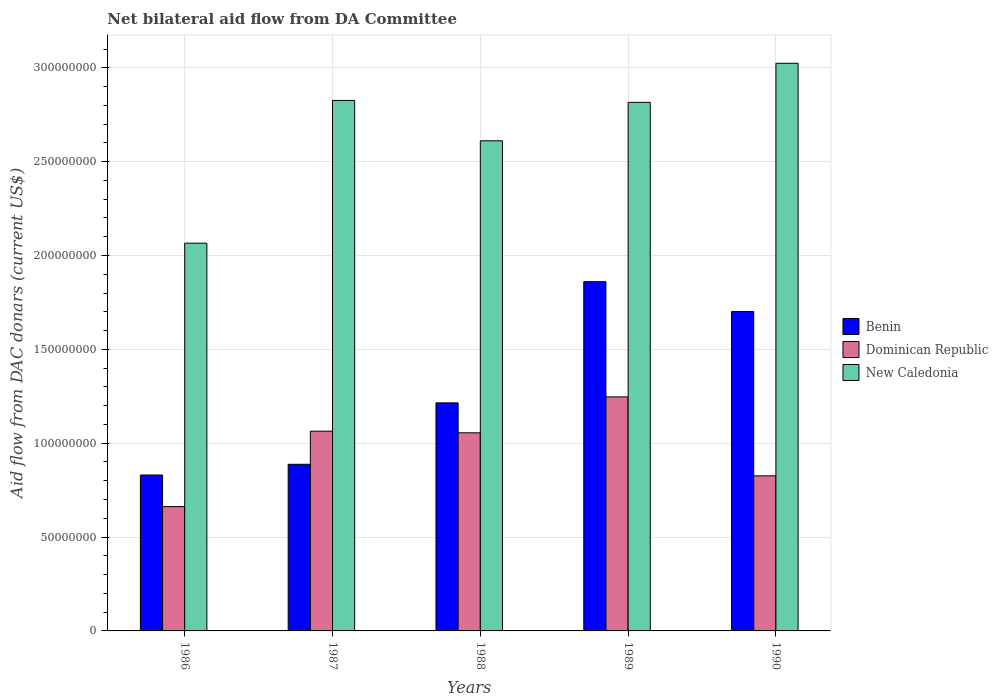How many groups of bars are there?
Provide a short and direct response. 5. Are the number of bars per tick equal to the number of legend labels?
Make the answer very short. Yes. Are the number of bars on each tick of the X-axis equal?
Provide a short and direct response. Yes. How many bars are there on the 3rd tick from the left?
Give a very brief answer. 3. In how many cases, is the number of bars for a given year not equal to the number of legend labels?
Ensure brevity in your answer.  0. What is the aid flow in in Dominican Republic in 1988?
Provide a short and direct response. 1.06e+08. Across all years, what is the maximum aid flow in in Benin?
Offer a very short reply. 1.86e+08. Across all years, what is the minimum aid flow in in Dominican Republic?
Provide a short and direct response. 6.62e+07. In which year was the aid flow in in Dominican Republic maximum?
Make the answer very short. 1989. In which year was the aid flow in in New Caledonia minimum?
Your answer should be very brief. 1986. What is the total aid flow in in Benin in the graph?
Give a very brief answer. 6.50e+08. What is the difference between the aid flow in in Dominican Republic in 1987 and that in 1989?
Make the answer very short. -1.83e+07. What is the average aid flow in in New Caledonia per year?
Ensure brevity in your answer.  2.67e+08. In the year 1986, what is the difference between the aid flow in in New Caledonia and aid flow in in Dominican Republic?
Make the answer very short. 1.40e+08. In how many years, is the aid flow in in Dominican Republic greater than 150000000 US$?
Give a very brief answer. 0. What is the ratio of the aid flow in in New Caledonia in 1987 to that in 1990?
Make the answer very short. 0.93. Is the aid flow in in Dominican Republic in 1988 less than that in 1990?
Your response must be concise. No. Is the difference between the aid flow in in New Caledonia in 1988 and 1990 greater than the difference between the aid flow in in Dominican Republic in 1988 and 1990?
Offer a terse response. No. What is the difference between the highest and the second highest aid flow in in Dominican Republic?
Your response must be concise. 1.83e+07. What is the difference between the highest and the lowest aid flow in in Dominican Republic?
Offer a very short reply. 5.84e+07. Is the sum of the aid flow in in Dominican Republic in 1987 and 1990 greater than the maximum aid flow in in New Caledonia across all years?
Offer a very short reply. No. What does the 3rd bar from the left in 1987 represents?
Offer a very short reply. New Caledonia. What does the 2nd bar from the right in 1990 represents?
Your response must be concise. Dominican Republic. Is it the case that in every year, the sum of the aid flow in in Dominican Republic and aid flow in in New Caledonia is greater than the aid flow in in Benin?
Provide a short and direct response. Yes. How many years are there in the graph?
Provide a short and direct response. 5. What is the difference between two consecutive major ticks on the Y-axis?
Offer a very short reply. 5.00e+07. Are the values on the major ticks of Y-axis written in scientific E-notation?
Your answer should be very brief. No. Does the graph contain any zero values?
Make the answer very short. No. What is the title of the graph?
Your answer should be very brief. Net bilateral aid flow from DA Committee. What is the label or title of the Y-axis?
Ensure brevity in your answer.  Aid flow from DAC donars (current US$). What is the Aid flow from DAC donars (current US$) in Benin in 1986?
Offer a terse response. 8.31e+07. What is the Aid flow from DAC donars (current US$) of Dominican Republic in 1986?
Your answer should be very brief. 6.62e+07. What is the Aid flow from DAC donars (current US$) of New Caledonia in 1986?
Your answer should be compact. 2.07e+08. What is the Aid flow from DAC donars (current US$) in Benin in 1987?
Provide a succinct answer. 8.88e+07. What is the Aid flow from DAC donars (current US$) of Dominican Republic in 1987?
Provide a succinct answer. 1.06e+08. What is the Aid flow from DAC donars (current US$) of New Caledonia in 1987?
Provide a short and direct response. 2.83e+08. What is the Aid flow from DAC donars (current US$) of Benin in 1988?
Provide a short and direct response. 1.21e+08. What is the Aid flow from DAC donars (current US$) of Dominican Republic in 1988?
Offer a terse response. 1.06e+08. What is the Aid flow from DAC donars (current US$) in New Caledonia in 1988?
Your answer should be compact. 2.61e+08. What is the Aid flow from DAC donars (current US$) in Benin in 1989?
Make the answer very short. 1.86e+08. What is the Aid flow from DAC donars (current US$) of Dominican Republic in 1989?
Keep it short and to the point. 1.25e+08. What is the Aid flow from DAC donars (current US$) of New Caledonia in 1989?
Your answer should be compact. 2.82e+08. What is the Aid flow from DAC donars (current US$) of Benin in 1990?
Keep it short and to the point. 1.70e+08. What is the Aid flow from DAC donars (current US$) of Dominican Republic in 1990?
Your response must be concise. 8.26e+07. What is the Aid flow from DAC donars (current US$) in New Caledonia in 1990?
Ensure brevity in your answer.  3.02e+08. Across all years, what is the maximum Aid flow from DAC donars (current US$) of Benin?
Provide a succinct answer. 1.86e+08. Across all years, what is the maximum Aid flow from DAC donars (current US$) of Dominican Republic?
Provide a succinct answer. 1.25e+08. Across all years, what is the maximum Aid flow from DAC donars (current US$) of New Caledonia?
Ensure brevity in your answer.  3.02e+08. Across all years, what is the minimum Aid flow from DAC donars (current US$) in Benin?
Offer a terse response. 8.31e+07. Across all years, what is the minimum Aid flow from DAC donars (current US$) of Dominican Republic?
Your response must be concise. 6.62e+07. Across all years, what is the minimum Aid flow from DAC donars (current US$) in New Caledonia?
Your answer should be very brief. 2.07e+08. What is the total Aid flow from DAC donars (current US$) of Benin in the graph?
Ensure brevity in your answer.  6.50e+08. What is the total Aid flow from DAC donars (current US$) in Dominican Republic in the graph?
Ensure brevity in your answer.  4.85e+08. What is the total Aid flow from DAC donars (current US$) in New Caledonia in the graph?
Your response must be concise. 1.33e+09. What is the difference between the Aid flow from DAC donars (current US$) of Benin in 1986 and that in 1987?
Your answer should be very brief. -5.71e+06. What is the difference between the Aid flow from DAC donars (current US$) in Dominican Republic in 1986 and that in 1987?
Provide a succinct answer. -4.02e+07. What is the difference between the Aid flow from DAC donars (current US$) of New Caledonia in 1986 and that in 1987?
Make the answer very short. -7.60e+07. What is the difference between the Aid flow from DAC donars (current US$) in Benin in 1986 and that in 1988?
Your answer should be compact. -3.84e+07. What is the difference between the Aid flow from DAC donars (current US$) of Dominican Republic in 1986 and that in 1988?
Your answer should be very brief. -3.93e+07. What is the difference between the Aid flow from DAC donars (current US$) of New Caledonia in 1986 and that in 1988?
Your response must be concise. -5.45e+07. What is the difference between the Aid flow from DAC donars (current US$) of Benin in 1986 and that in 1989?
Offer a terse response. -1.03e+08. What is the difference between the Aid flow from DAC donars (current US$) of Dominican Republic in 1986 and that in 1989?
Your response must be concise. -5.84e+07. What is the difference between the Aid flow from DAC donars (current US$) in New Caledonia in 1986 and that in 1989?
Provide a short and direct response. -7.50e+07. What is the difference between the Aid flow from DAC donars (current US$) in Benin in 1986 and that in 1990?
Make the answer very short. -8.71e+07. What is the difference between the Aid flow from DAC donars (current US$) in Dominican Republic in 1986 and that in 1990?
Your answer should be compact. -1.64e+07. What is the difference between the Aid flow from DAC donars (current US$) in New Caledonia in 1986 and that in 1990?
Provide a short and direct response. -9.58e+07. What is the difference between the Aid flow from DAC donars (current US$) of Benin in 1987 and that in 1988?
Keep it short and to the point. -3.27e+07. What is the difference between the Aid flow from DAC donars (current US$) of Dominican Republic in 1987 and that in 1988?
Give a very brief answer. 8.70e+05. What is the difference between the Aid flow from DAC donars (current US$) of New Caledonia in 1987 and that in 1988?
Keep it short and to the point. 2.15e+07. What is the difference between the Aid flow from DAC donars (current US$) in Benin in 1987 and that in 1989?
Give a very brief answer. -9.73e+07. What is the difference between the Aid flow from DAC donars (current US$) of Dominican Republic in 1987 and that in 1989?
Give a very brief answer. -1.83e+07. What is the difference between the Aid flow from DAC donars (current US$) of New Caledonia in 1987 and that in 1989?
Provide a short and direct response. 1.03e+06. What is the difference between the Aid flow from DAC donars (current US$) of Benin in 1987 and that in 1990?
Offer a very short reply. -8.14e+07. What is the difference between the Aid flow from DAC donars (current US$) in Dominican Republic in 1987 and that in 1990?
Offer a terse response. 2.38e+07. What is the difference between the Aid flow from DAC donars (current US$) of New Caledonia in 1987 and that in 1990?
Provide a short and direct response. -1.98e+07. What is the difference between the Aid flow from DAC donars (current US$) in Benin in 1988 and that in 1989?
Your answer should be compact. -6.46e+07. What is the difference between the Aid flow from DAC donars (current US$) of Dominican Republic in 1988 and that in 1989?
Your response must be concise. -1.91e+07. What is the difference between the Aid flow from DAC donars (current US$) of New Caledonia in 1988 and that in 1989?
Make the answer very short. -2.05e+07. What is the difference between the Aid flow from DAC donars (current US$) of Benin in 1988 and that in 1990?
Provide a short and direct response. -4.87e+07. What is the difference between the Aid flow from DAC donars (current US$) in Dominican Republic in 1988 and that in 1990?
Ensure brevity in your answer.  2.29e+07. What is the difference between the Aid flow from DAC donars (current US$) of New Caledonia in 1988 and that in 1990?
Your answer should be compact. -4.13e+07. What is the difference between the Aid flow from DAC donars (current US$) of Benin in 1989 and that in 1990?
Offer a very short reply. 1.59e+07. What is the difference between the Aid flow from DAC donars (current US$) of Dominican Republic in 1989 and that in 1990?
Make the answer very short. 4.20e+07. What is the difference between the Aid flow from DAC donars (current US$) in New Caledonia in 1989 and that in 1990?
Make the answer very short. -2.08e+07. What is the difference between the Aid flow from DAC donars (current US$) of Benin in 1986 and the Aid flow from DAC donars (current US$) of Dominican Republic in 1987?
Offer a very short reply. -2.34e+07. What is the difference between the Aid flow from DAC donars (current US$) of Benin in 1986 and the Aid flow from DAC donars (current US$) of New Caledonia in 1987?
Make the answer very short. -2.00e+08. What is the difference between the Aid flow from DAC donars (current US$) in Dominican Republic in 1986 and the Aid flow from DAC donars (current US$) in New Caledonia in 1987?
Offer a very short reply. -2.16e+08. What is the difference between the Aid flow from DAC donars (current US$) in Benin in 1986 and the Aid flow from DAC donars (current US$) in Dominican Republic in 1988?
Give a very brief answer. -2.25e+07. What is the difference between the Aid flow from DAC donars (current US$) of Benin in 1986 and the Aid flow from DAC donars (current US$) of New Caledonia in 1988?
Ensure brevity in your answer.  -1.78e+08. What is the difference between the Aid flow from DAC donars (current US$) in Dominican Republic in 1986 and the Aid flow from DAC donars (current US$) in New Caledonia in 1988?
Your answer should be compact. -1.95e+08. What is the difference between the Aid flow from DAC donars (current US$) of Benin in 1986 and the Aid flow from DAC donars (current US$) of Dominican Republic in 1989?
Provide a succinct answer. -4.16e+07. What is the difference between the Aid flow from DAC donars (current US$) in Benin in 1986 and the Aid flow from DAC donars (current US$) in New Caledonia in 1989?
Provide a succinct answer. -1.99e+08. What is the difference between the Aid flow from DAC donars (current US$) of Dominican Republic in 1986 and the Aid flow from DAC donars (current US$) of New Caledonia in 1989?
Keep it short and to the point. -2.15e+08. What is the difference between the Aid flow from DAC donars (current US$) in Benin in 1986 and the Aid flow from DAC donars (current US$) in Dominican Republic in 1990?
Keep it short and to the point. 4.40e+05. What is the difference between the Aid flow from DAC donars (current US$) of Benin in 1986 and the Aid flow from DAC donars (current US$) of New Caledonia in 1990?
Offer a very short reply. -2.19e+08. What is the difference between the Aid flow from DAC donars (current US$) of Dominican Republic in 1986 and the Aid flow from DAC donars (current US$) of New Caledonia in 1990?
Offer a terse response. -2.36e+08. What is the difference between the Aid flow from DAC donars (current US$) of Benin in 1987 and the Aid flow from DAC donars (current US$) of Dominican Republic in 1988?
Offer a terse response. -1.68e+07. What is the difference between the Aid flow from DAC donars (current US$) of Benin in 1987 and the Aid flow from DAC donars (current US$) of New Caledonia in 1988?
Offer a very short reply. -1.72e+08. What is the difference between the Aid flow from DAC donars (current US$) of Dominican Republic in 1987 and the Aid flow from DAC donars (current US$) of New Caledonia in 1988?
Ensure brevity in your answer.  -1.55e+08. What is the difference between the Aid flow from DAC donars (current US$) in Benin in 1987 and the Aid flow from DAC donars (current US$) in Dominican Republic in 1989?
Give a very brief answer. -3.59e+07. What is the difference between the Aid flow from DAC donars (current US$) in Benin in 1987 and the Aid flow from DAC donars (current US$) in New Caledonia in 1989?
Give a very brief answer. -1.93e+08. What is the difference between the Aid flow from DAC donars (current US$) of Dominican Republic in 1987 and the Aid flow from DAC donars (current US$) of New Caledonia in 1989?
Provide a short and direct response. -1.75e+08. What is the difference between the Aid flow from DAC donars (current US$) of Benin in 1987 and the Aid flow from DAC donars (current US$) of Dominican Republic in 1990?
Your response must be concise. 6.15e+06. What is the difference between the Aid flow from DAC donars (current US$) in Benin in 1987 and the Aid flow from DAC donars (current US$) in New Caledonia in 1990?
Provide a succinct answer. -2.14e+08. What is the difference between the Aid flow from DAC donars (current US$) in Dominican Republic in 1987 and the Aid flow from DAC donars (current US$) in New Caledonia in 1990?
Offer a terse response. -1.96e+08. What is the difference between the Aid flow from DAC donars (current US$) in Benin in 1988 and the Aid flow from DAC donars (current US$) in Dominican Republic in 1989?
Your answer should be compact. -3.19e+06. What is the difference between the Aid flow from DAC donars (current US$) in Benin in 1988 and the Aid flow from DAC donars (current US$) in New Caledonia in 1989?
Provide a short and direct response. -1.60e+08. What is the difference between the Aid flow from DAC donars (current US$) in Dominican Republic in 1988 and the Aid flow from DAC donars (current US$) in New Caledonia in 1989?
Provide a succinct answer. -1.76e+08. What is the difference between the Aid flow from DAC donars (current US$) of Benin in 1988 and the Aid flow from DAC donars (current US$) of Dominican Republic in 1990?
Your answer should be very brief. 3.89e+07. What is the difference between the Aid flow from DAC donars (current US$) in Benin in 1988 and the Aid flow from DAC donars (current US$) in New Caledonia in 1990?
Make the answer very short. -1.81e+08. What is the difference between the Aid flow from DAC donars (current US$) in Dominican Republic in 1988 and the Aid flow from DAC donars (current US$) in New Caledonia in 1990?
Your response must be concise. -1.97e+08. What is the difference between the Aid flow from DAC donars (current US$) of Benin in 1989 and the Aid flow from DAC donars (current US$) of Dominican Republic in 1990?
Your response must be concise. 1.03e+08. What is the difference between the Aid flow from DAC donars (current US$) in Benin in 1989 and the Aid flow from DAC donars (current US$) in New Caledonia in 1990?
Make the answer very short. -1.16e+08. What is the difference between the Aid flow from DAC donars (current US$) of Dominican Republic in 1989 and the Aid flow from DAC donars (current US$) of New Caledonia in 1990?
Provide a short and direct response. -1.78e+08. What is the average Aid flow from DAC donars (current US$) in Benin per year?
Provide a short and direct response. 1.30e+08. What is the average Aid flow from DAC donars (current US$) in Dominican Republic per year?
Keep it short and to the point. 9.71e+07. What is the average Aid flow from DAC donars (current US$) of New Caledonia per year?
Make the answer very short. 2.67e+08. In the year 1986, what is the difference between the Aid flow from DAC donars (current US$) in Benin and Aid flow from DAC donars (current US$) in Dominican Republic?
Your answer should be very brief. 1.68e+07. In the year 1986, what is the difference between the Aid flow from DAC donars (current US$) of Benin and Aid flow from DAC donars (current US$) of New Caledonia?
Your response must be concise. -1.24e+08. In the year 1986, what is the difference between the Aid flow from DAC donars (current US$) in Dominican Republic and Aid flow from DAC donars (current US$) in New Caledonia?
Provide a succinct answer. -1.40e+08. In the year 1987, what is the difference between the Aid flow from DAC donars (current US$) in Benin and Aid flow from DAC donars (current US$) in Dominican Republic?
Give a very brief answer. -1.76e+07. In the year 1987, what is the difference between the Aid flow from DAC donars (current US$) of Benin and Aid flow from DAC donars (current US$) of New Caledonia?
Keep it short and to the point. -1.94e+08. In the year 1987, what is the difference between the Aid flow from DAC donars (current US$) in Dominican Republic and Aid flow from DAC donars (current US$) in New Caledonia?
Make the answer very short. -1.76e+08. In the year 1988, what is the difference between the Aid flow from DAC donars (current US$) of Benin and Aid flow from DAC donars (current US$) of Dominican Republic?
Give a very brief answer. 1.59e+07. In the year 1988, what is the difference between the Aid flow from DAC donars (current US$) of Benin and Aid flow from DAC donars (current US$) of New Caledonia?
Offer a very short reply. -1.40e+08. In the year 1988, what is the difference between the Aid flow from DAC donars (current US$) of Dominican Republic and Aid flow from DAC donars (current US$) of New Caledonia?
Your answer should be compact. -1.56e+08. In the year 1989, what is the difference between the Aid flow from DAC donars (current US$) of Benin and Aid flow from DAC donars (current US$) of Dominican Republic?
Give a very brief answer. 6.14e+07. In the year 1989, what is the difference between the Aid flow from DAC donars (current US$) in Benin and Aid flow from DAC donars (current US$) in New Caledonia?
Make the answer very short. -9.55e+07. In the year 1989, what is the difference between the Aid flow from DAC donars (current US$) of Dominican Republic and Aid flow from DAC donars (current US$) of New Caledonia?
Offer a terse response. -1.57e+08. In the year 1990, what is the difference between the Aid flow from DAC donars (current US$) of Benin and Aid flow from DAC donars (current US$) of Dominican Republic?
Offer a terse response. 8.75e+07. In the year 1990, what is the difference between the Aid flow from DAC donars (current US$) in Benin and Aid flow from DAC donars (current US$) in New Caledonia?
Make the answer very short. -1.32e+08. In the year 1990, what is the difference between the Aid flow from DAC donars (current US$) of Dominican Republic and Aid flow from DAC donars (current US$) of New Caledonia?
Ensure brevity in your answer.  -2.20e+08. What is the ratio of the Aid flow from DAC donars (current US$) of Benin in 1986 to that in 1987?
Keep it short and to the point. 0.94. What is the ratio of the Aid flow from DAC donars (current US$) of Dominican Republic in 1986 to that in 1987?
Your answer should be compact. 0.62. What is the ratio of the Aid flow from DAC donars (current US$) in New Caledonia in 1986 to that in 1987?
Offer a very short reply. 0.73. What is the ratio of the Aid flow from DAC donars (current US$) of Benin in 1986 to that in 1988?
Your response must be concise. 0.68. What is the ratio of the Aid flow from DAC donars (current US$) of Dominican Republic in 1986 to that in 1988?
Provide a short and direct response. 0.63. What is the ratio of the Aid flow from DAC donars (current US$) of New Caledonia in 1986 to that in 1988?
Give a very brief answer. 0.79. What is the ratio of the Aid flow from DAC donars (current US$) in Benin in 1986 to that in 1989?
Your answer should be compact. 0.45. What is the ratio of the Aid flow from DAC donars (current US$) in Dominican Republic in 1986 to that in 1989?
Give a very brief answer. 0.53. What is the ratio of the Aid flow from DAC donars (current US$) in New Caledonia in 1986 to that in 1989?
Provide a succinct answer. 0.73. What is the ratio of the Aid flow from DAC donars (current US$) in Benin in 1986 to that in 1990?
Ensure brevity in your answer.  0.49. What is the ratio of the Aid flow from DAC donars (current US$) of Dominican Republic in 1986 to that in 1990?
Ensure brevity in your answer.  0.8. What is the ratio of the Aid flow from DAC donars (current US$) in New Caledonia in 1986 to that in 1990?
Offer a terse response. 0.68. What is the ratio of the Aid flow from DAC donars (current US$) of Benin in 1987 to that in 1988?
Keep it short and to the point. 0.73. What is the ratio of the Aid flow from DAC donars (current US$) of Dominican Republic in 1987 to that in 1988?
Keep it short and to the point. 1.01. What is the ratio of the Aid flow from DAC donars (current US$) of New Caledonia in 1987 to that in 1988?
Your response must be concise. 1.08. What is the ratio of the Aid flow from DAC donars (current US$) of Benin in 1987 to that in 1989?
Offer a terse response. 0.48. What is the ratio of the Aid flow from DAC donars (current US$) of Dominican Republic in 1987 to that in 1989?
Give a very brief answer. 0.85. What is the ratio of the Aid flow from DAC donars (current US$) of Benin in 1987 to that in 1990?
Offer a terse response. 0.52. What is the ratio of the Aid flow from DAC donars (current US$) of Dominican Republic in 1987 to that in 1990?
Give a very brief answer. 1.29. What is the ratio of the Aid flow from DAC donars (current US$) of New Caledonia in 1987 to that in 1990?
Provide a short and direct response. 0.93. What is the ratio of the Aid flow from DAC donars (current US$) of Benin in 1988 to that in 1989?
Your answer should be compact. 0.65. What is the ratio of the Aid flow from DAC donars (current US$) of Dominican Republic in 1988 to that in 1989?
Provide a short and direct response. 0.85. What is the ratio of the Aid flow from DAC donars (current US$) of New Caledonia in 1988 to that in 1989?
Give a very brief answer. 0.93. What is the ratio of the Aid flow from DAC donars (current US$) of Benin in 1988 to that in 1990?
Offer a terse response. 0.71. What is the ratio of the Aid flow from DAC donars (current US$) of Dominican Republic in 1988 to that in 1990?
Your answer should be very brief. 1.28. What is the ratio of the Aid flow from DAC donars (current US$) in New Caledonia in 1988 to that in 1990?
Your response must be concise. 0.86. What is the ratio of the Aid flow from DAC donars (current US$) in Benin in 1989 to that in 1990?
Your answer should be very brief. 1.09. What is the ratio of the Aid flow from DAC donars (current US$) of Dominican Republic in 1989 to that in 1990?
Your response must be concise. 1.51. What is the ratio of the Aid flow from DAC donars (current US$) in New Caledonia in 1989 to that in 1990?
Your answer should be very brief. 0.93. What is the difference between the highest and the second highest Aid flow from DAC donars (current US$) of Benin?
Provide a succinct answer. 1.59e+07. What is the difference between the highest and the second highest Aid flow from DAC donars (current US$) of Dominican Republic?
Give a very brief answer. 1.83e+07. What is the difference between the highest and the second highest Aid flow from DAC donars (current US$) in New Caledonia?
Make the answer very short. 1.98e+07. What is the difference between the highest and the lowest Aid flow from DAC donars (current US$) in Benin?
Your response must be concise. 1.03e+08. What is the difference between the highest and the lowest Aid flow from DAC donars (current US$) of Dominican Republic?
Provide a short and direct response. 5.84e+07. What is the difference between the highest and the lowest Aid flow from DAC donars (current US$) in New Caledonia?
Keep it short and to the point. 9.58e+07. 